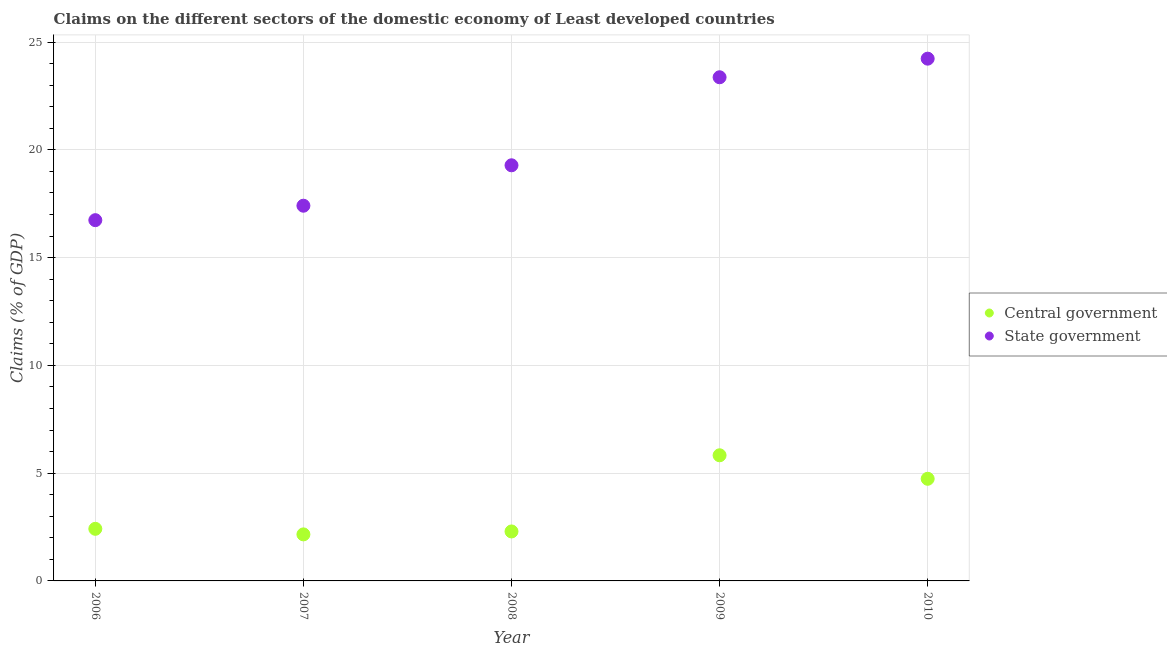What is the claims on central government in 2006?
Offer a very short reply. 2.42. Across all years, what is the maximum claims on state government?
Your response must be concise. 24.23. Across all years, what is the minimum claims on state government?
Give a very brief answer. 16.74. In which year was the claims on state government maximum?
Your answer should be compact. 2010. In which year was the claims on state government minimum?
Your response must be concise. 2006. What is the total claims on central government in the graph?
Ensure brevity in your answer.  17.44. What is the difference between the claims on state government in 2009 and that in 2010?
Ensure brevity in your answer.  -0.86. What is the difference between the claims on central government in 2009 and the claims on state government in 2008?
Your response must be concise. -13.45. What is the average claims on state government per year?
Offer a terse response. 20.2. In the year 2010, what is the difference between the claims on state government and claims on central government?
Ensure brevity in your answer.  19.49. What is the ratio of the claims on state government in 2008 to that in 2010?
Give a very brief answer. 0.8. What is the difference between the highest and the second highest claims on central government?
Your response must be concise. 1.09. What is the difference between the highest and the lowest claims on state government?
Give a very brief answer. 7.49. In how many years, is the claims on state government greater than the average claims on state government taken over all years?
Your response must be concise. 2. Is the claims on state government strictly greater than the claims on central government over the years?
Give a very brief answer. Yes. How many dotlines are there?
Provide a short and direct response. 2. What is the difference between two consecutive major ticks on the Y-axis?
Give a very brief answer. 5. Are the values on the major ticks of Y-axis written in scientific E-notation?
Offer a very short reply. No. Where does the legend appear in the graph?
Provide a succinct answer. Center right. How many legend labels are there?
Give a very brief answer. 2. How are the legend labels stacked?
Provide a succinct answer. Vertical. What is the title of the graph?
Keep it short and to the point. Claims on the different sectors of the domestic economy of Least developed countries. Does "Broad money growth" appear as one of the legend labels in the graph?
Keep it short and to the point. No. What is the label or title of the Y-axis?
Your answer should be very brief. Claims (% of GDP). What is the Claims (% of GDP) of Central government in 2006?
Provide a succinct answer. 2.42. What is the Claims (% of GDP) in State government in 2006?
Provide a short and direct response. 16.74. What is the Claims (% of GDP) in Central government in 2007?
Your answer should be very brief. 2.16. What is the Claims (% of GDP) in State government in 2007?
Your answer should be compact. 17.41. What is the Claims (% of GDP) in Central government in 2008?
Your answer should be compact. 2.3. What is the Claims (% of GDP) in State government in 2008?
Keep it short and to the point. 19.28. What is the Claims (% of GDP) of Central government in 2009?
Your answer should be very brief. 5.83. What is the Claims (% of GDP) of State government in 2009?
Keep it short and to the point. 23.37. What is the Claims (% of GDP) in Central government in 2010?
Offer a terse response. 4.74. What is the Claims (% of GDP) of State government in 2010?
Ensure brevity in your answer.  24.23. Across all years, what is the maximum Claims (% of GDP) of Central government?
Make the answer very short. 5.83. Across all years, what is the maximum Claims (% of GDP) of State government?
Offer a very short reply. 24.23. Across all years, what is the minimum Claims (% of GDP) of Central government?
Offer a very short reply. 2.16. Across all years, what is the minimum Claims (% of GDP) in State government?
Provide a short and direct response. 16.74. What is the total Claims (% of GDP) in Central government in the graph?
Your answer should be compact. 17.44. What is the total Claims (% of GDP) in State government in the graph?
Keep it short and to the point. 101.02. What is the difference between the Claims (% of GDP) in Central government in 2006 and that in 2007?
Your answer should be compact. 0.26. What is the difference between the Claims (% of GDP) of State government in 2006 and that in 2007?
Your answer should be very brief. -0.67. What is the difference between the Claims (% of GDP) of Central government in 2006 and that in 2008?
Make the answer very short. 0.12. What is the difference between the Claims (% of GDP) of State government in 2006 and that in 2008?
Keep it short and to the point. -2.55. What is the difference between the Claims (% of GDP) of Central government in 2006 and that in 2009?
Make the answer very short. -3.41. What is the difference between the Claims (% of GDP) in State government in 2006 and that in 2009?
Ensure brevity in your answer.  -6.63. What is the difference between the Claims (% of GDP) of Central government in 2006 and that in 2010?
Ensure brevity in your answer.  -2.32. What is the difference between the Claims (% of GDP) of State government in 2006 and that in 2010?
Provide a short and direct response. -7.49. What is the difference between the Claims (% of GDP) in Central government in 2007 and that in 2008?
Ensure brevity in your answer.  -0.14. What is the difference between the Claims (% of GDP) of State government in 2007 and that in 2008?
Your response must be concise. -1.88. What is the difference between the Claims (% of GDP) in Central government in 2007 and that in 2009?
Ensure brevity in your answer.  -3.67. What is the difference between the Claims (% of GDP) of State government in 2007 and that in 2009?
Offer a very short reply. -5.96. What is the difference between the Claims (% of GDP) of Central government in 2007 and that in 2010?
Your answer should be very brief. -2.58. What is the difference between the Claims (% of GDP) in State government in 2007 and that in 2010?
Provide a short and direct response. -6.82. What is the difference between the Claims (% of GDP) of Central government in 2008 and that in 2009?
Provide a succinct answer. -3.53. What is the difference between the Claims (% of GDP) in State government in 2008 and that in 2009?
Provide a succinct answer. -4.08. What is the difference between the Claims (% of GDP) of Central government in 2008 and that in 2010?
Your answer should be compact. -2.44. What is the difference between the Claims (% of GDP) of State government in 2008 and that in 2010?
Make the answer very short. -4.95. What is the difference between the Claims (% of GDP) in Central government in 2009 and that in 2010?
Offer a very short reply. 1.09. What is the difference between the Claims (% of GDP) in State government in 2009 and that in 2010?
Your answer should be very brief. -0.86. What is the difference between the Claims (% of GDP) of Central government in 2006 and the Claims (% of GDP) of State government in 2007?
Give a very brief answer. -14.99. What is the difference between the Claims (% of GDP) in Central government in 2006 and the Claims (% of GDP) in State government in 2008?
Keep it short and to the point. -16.86. What is the difference between the Claims (% of GDP) of Central government in 2006 and the Claims (% of GDP) of State government in 2009?
Give a very brief answer. -20.95. What is the difference between the Claims (% of GDP) in Central government in 2006 and the Claims (% of GDP) in State government in 2010?
Your answer should be very brief. -21.81. What is the difference between the Claims (% of GDP) in Central government in 2007 and the Claims (% of GDP) in State government in 2008?
Make the answer very short. -17.12. What is the difference between the Claims (% of GDP) of Central government in 2007 and the Claims (% of GDP) of State government in 2009?
Keep it short and to the point. -21.21. What is the difference between the Claims (% of GDP) in Central government in 2007 and the Claims (% of GDP) in State government in 2010?
Offer a very short reply. -22.07. What is the difference between the Claims (% of GDP) in Central government in 2008 and the Claims (% of GDP) in State government in 2009?
Ensure brevity in your answer.  -21.07. What is the difference between the Claims (% of GDP) of Central government in 2008 and the Claims (% of GDP) of State government in 2010?
Your answer should be very brief. -21.93. What is the difference between the Claims (% of GDP) in Central government in 2009 and the Claims (% of GDP) in State government in 2010?
Your answer should be compact. -18.4. What is the average Claims (% of GDP) of Central government per year?
Keep it short and to the point. 3.49. What is the average Claims (% of GDP) of State government per year?
Provide a short and direct response. 20.2. In the year 2006, what is the difference between the Claims (% of GDP) of Central government and Claims (% of GDP) of State government?
Ensure brevity in your answer.  -14.32. In the year 2007, what is the difference between the Claims (% of GDP) in Central government and Claims (% of GDP) in State government?
Give a very brief answer. -15.25. In the year 2008, what is the difference between the Claims (% of GDP) in Central government and Claims (% of GDP) in State government?
Make the answer very short. -16.99. In the year 2009, what is the difference between the Claims (% of GDP) of Central government and Claims (% of GDP) of State government?
Give a very brief answer. -17.54. In the year 2010, what is the difference between the Claims (% of GDP) of Central government and Claims (% of GDP) of State government?
Keep it short and to the point. -19.49. What is the ratio of the Claims (% of GDP) in Central government in 2006 to that in 2007?
Give a very brief answer. 1.12. What is the ratio of the Claims (% of GDP) in State government in 2006 to that in 2007?
Ensure brevity in your answer.  0.96. What is the ratio of the Claims (% of GDP) in Central government in 2006 to that in 2008?
Give a very brief answer. 1.05. What is the ratio of the Claims (% of GDP) in State government in 2006 to that in 2008?
Make the answer very short. 0.87. What is the ratio of the Claims (% of GDP) in Central government in 2006 to that in 2009?
Your response must be concise. 0.41. What is the ratio of the Claims (% of GDP) in State government in 2006 to that in 2009?
Keep it short and to the point. 0.72. What is the ratio of the Claims (% of GDP) of Central government in 2006 to that in 2010?
Make the answer very short. 0.51. What is the ratio of the Claims (% of GDP) of State government in 2006 to that in 2010?
Your response must be concise. 0.69. What is the ratio of the Claims (% of GDP) of Central government in 2007 to that in 2008?
Keep it short and to the point. 0.94. What is the ratio of the Claims (% of GDP) in State government in 2007 to that in 2008?
Your answer should be compact. 0.9. What is the ratio of the Claims (% of GDP) in Central government in 2007 to that in 2009?
Your answer should be very brief. 0.37. What is the ratio of the Claims (% of GDP) of State government in 2007 to that in 2009?
Provide a short and direct response. 0.74. What is the ratio of the Claims (% of GDP) in Central government in 2007 to that in 2010?
Keep it short and to the point. 0.46. What is the ratio of the Claims (% of GDP) in State government in 2007 to that in 2010?
Your response must be concise. 0.72. What is the ratio of the Claims (% of GDP) in Central government in 2008 to that in 2009?
Give a very brief answer. 0.39. What is the ratio of the Claims (% of GDP) in State government in 2008 to that in 2009?
Your answer should be very brief. 0.83. What is the ratio of the Claims (% of GDP) of Central government in 2008 to that in 2010?
Your response must be concise. 0.48. What is the ratio of the Claims (% of GDP) of State government in 2008 to that in 2010?
Ensure brevity in your answer.  0.8. What is the ratio of the Claims (% of GDP) in Central government in 2009 to that in 2010?
Keep it short and to the point. 1.23. What is the ratio of the Claims (% of GDP) of State government in 2009 to that in 2010?
Make the answer very short. 0.96. What is the difference between the highest and the second highest Claims (% of GDP) in Central government?
Give a very brief answer. 1.09. What is the difference between the highest and the second highest Claims (% of GDP) in State government?
Your answer should be very brief. 0.86. What is the difference between the highest and the lowest Claims (% of GDP) in Central government?
Ensure brevity in your answer.  3.67. What is the difference between the highest and the lowest Claims (% of GDP) in State government?
Your answer should be very brief. 7.49. 